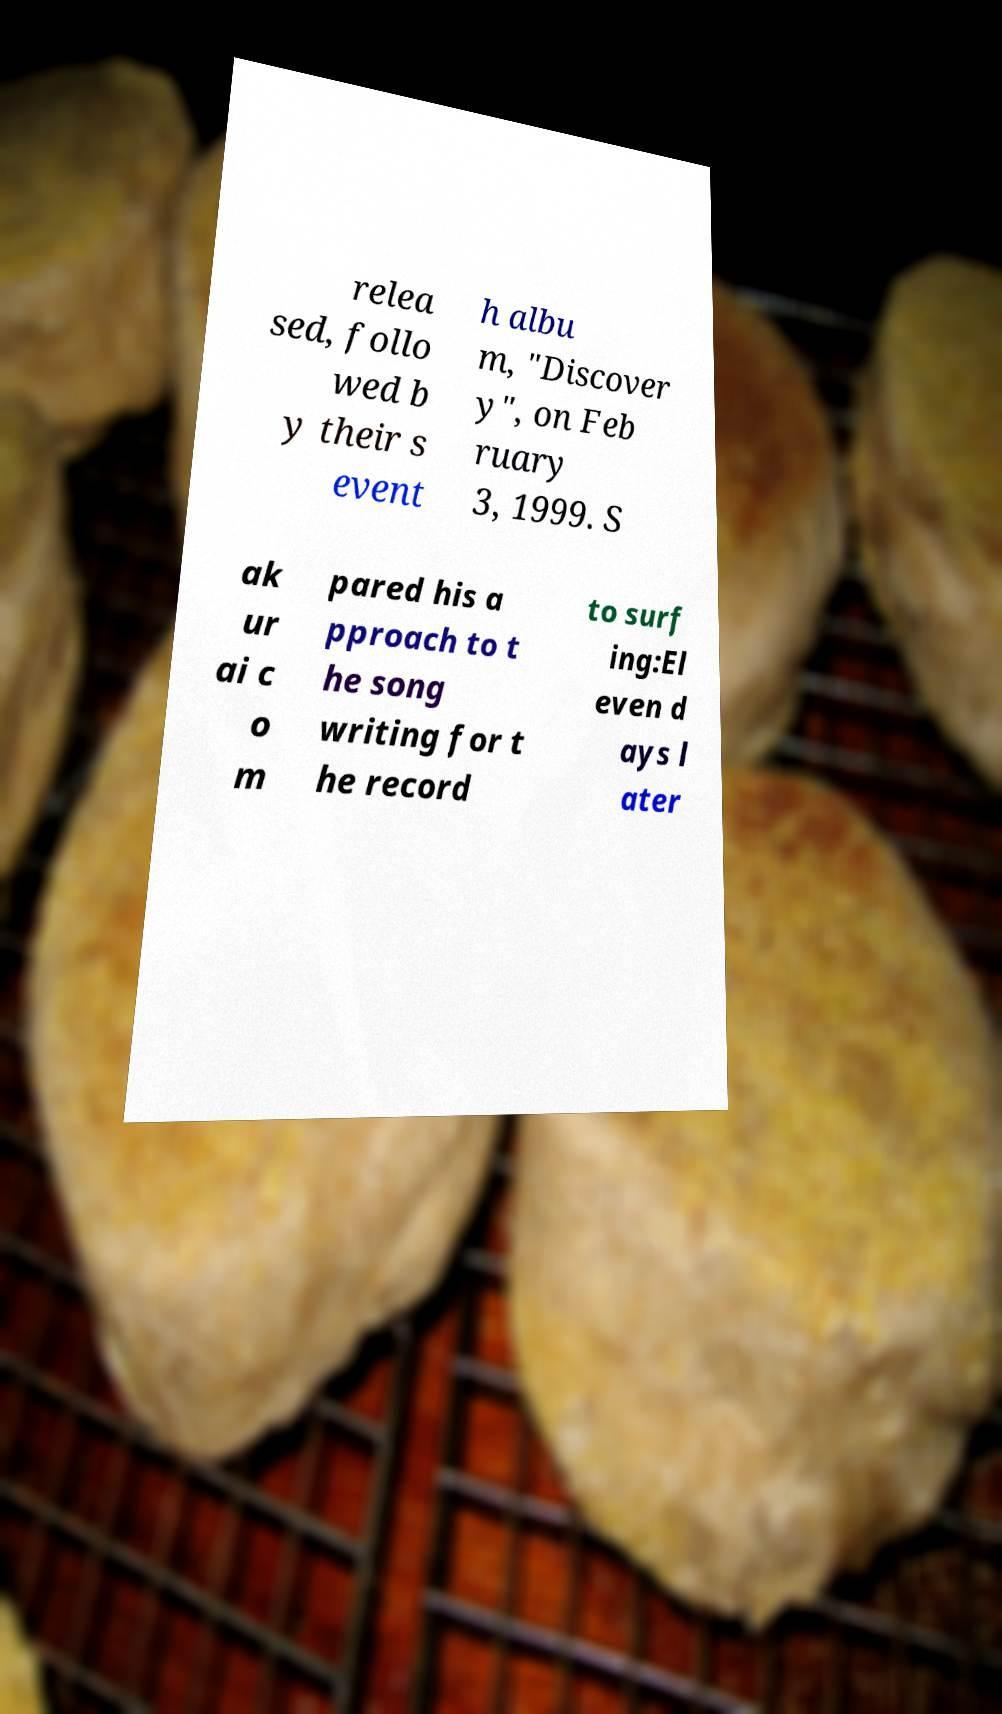I need the written content from this picture converted into text. Can you do that? relea sed, follo wed b y their s event h albu m, "Discover y", on Feb ruary 3, 1999. S ak ur ai c o m pared his a pproach to t he song writing for t he record to surf ing:El even d ays l ater 